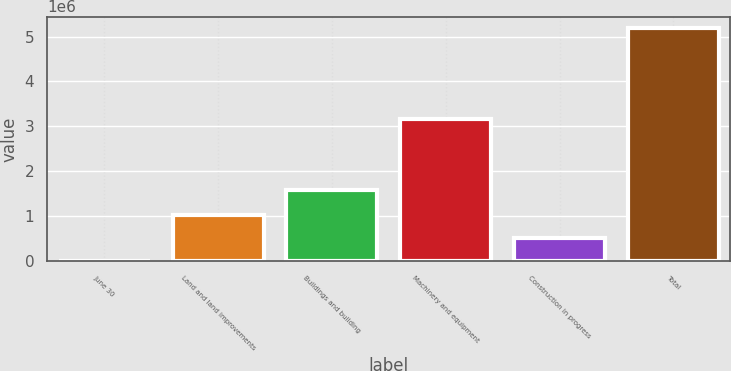Convert chart. <chart><loc_0><loc_0><loc_500><loc_500><bar_chart><fcel>June 30<fcel>Land and land improvements<fcel>Buildings and building<fcel>Machinery and equipment<fcel>Construction in progress<fcel>Total<nl><fcel>2017<fcel>1.03896e+06<fcel>1.57546e+06<fcel>3.16788e+06<fcel>520490<fcel>5.18675e+06<nl></chart> 